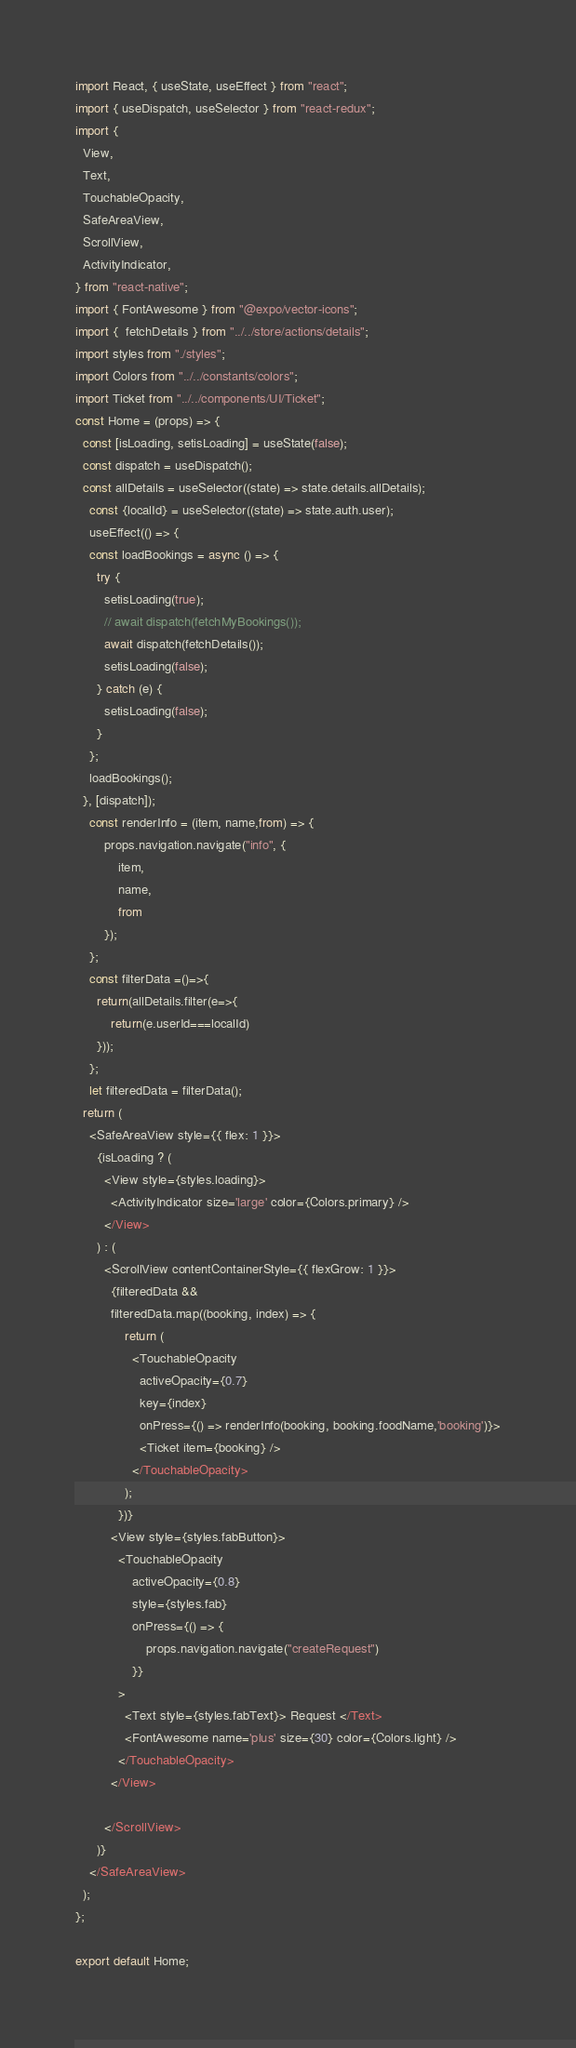Convert code to text. <code><loc_0><loc_0><loc_500><loc_500><_JavaScript_>import React, { useState, useEffect } from "react";
import { useDispatch, useSelector } from "react-redux";
import {
  View,
  Text,
  TouchableOpacity,
  SafeAreaView,
  ScrollView,
  ActivityIndicator,
} from "react-native";
import { FontAwesome } from "@expo/vector-icons";
import {  fetchDetails } from "../../store/actions/details";
import styles from "./styles";
import Colors from "../../constants/colors";
import Ticket from "../../components/UI/Ticket";
const Home = (props) => {
  const [isLoading, setisLoading] = useState(false);
  const dispatch = useDispatch();
  const allDetails = useSelector((state) => state.details.allDetails);
    const {localId} = useSelector((state) => state.auth.user);
    useEffect(() => {
    const loadBookings = async () => {
      try {
        setisLoading(true);
        // await dispatch(fetchMyBookings());
        await dispatch(fetchDetails());
        setisLoading(false);
      } catch (e) {
        setisLoading(false);
      }
    };
    loadBookings();
  }, [dispatch]);
    const renderInfo = (item, name,from) => {
        props.navigation.navigate("info", {
            item,
            name,
            from
        });
    };
    const filterData =()=>{
      return(allDetails.filter(e=>{
          return(e.userId===localId)
      }));
    };
    let filteredData = filterData();
  return (
    <SafeAreaView style={{ flex: 1 }}>
      {isLoading ? (
        <View style={styles.loading}>
          <ActivityIndicator size='large' color={Colors.primary} />
        </View>
      ) : (
        <ScrollView contentContainerStyle={{ flexGrow: 1 }}>
          {filteredData &&
          filteredData.map((booking, index) => {
              return (
                <TouchableOpacity
                  activeOpacity={0.7}
                  key={index}
                  onPress={() => renderInfo(booking, booking.foodName,'booking')}>
                  <Ticket item={booking} />
                </TouchableOpacity>
              );
            })}
          <View style={styles.fabButton}>
            <TouchableOpacity
                activeOpacity={0.8}
                style={styles.fab}
                onPress={() => {
                    props.navigation.navigate("createRequest")
                }}
            >
              <Text style={styles.fabText}> Request </Text>
              <FontAwesome name='plus' size={30} color={Colors.light} />
            </TouchableOpacity>
          </View>

        </ScrollView>
      )}
    </SafeAreaView>
  );
};

export default Home;
</code> 